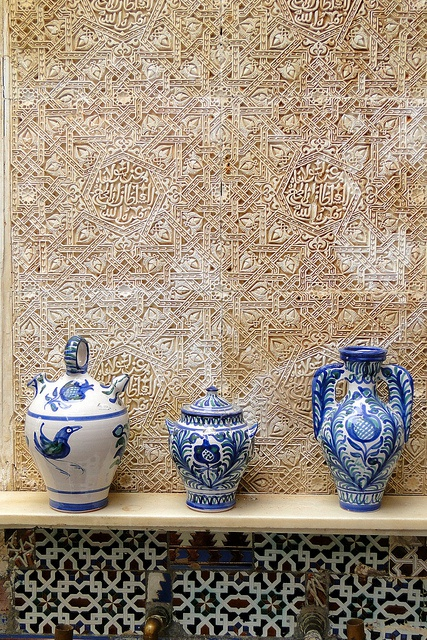Describe the objects in this image and their specific colors. I can see vase in tan, white, darkgray, and gray tones, vase in tan, navy, darkgray, gray, and lightgray tones, and vase in tan, darkgray, black, gray, and navy tones in this image. 